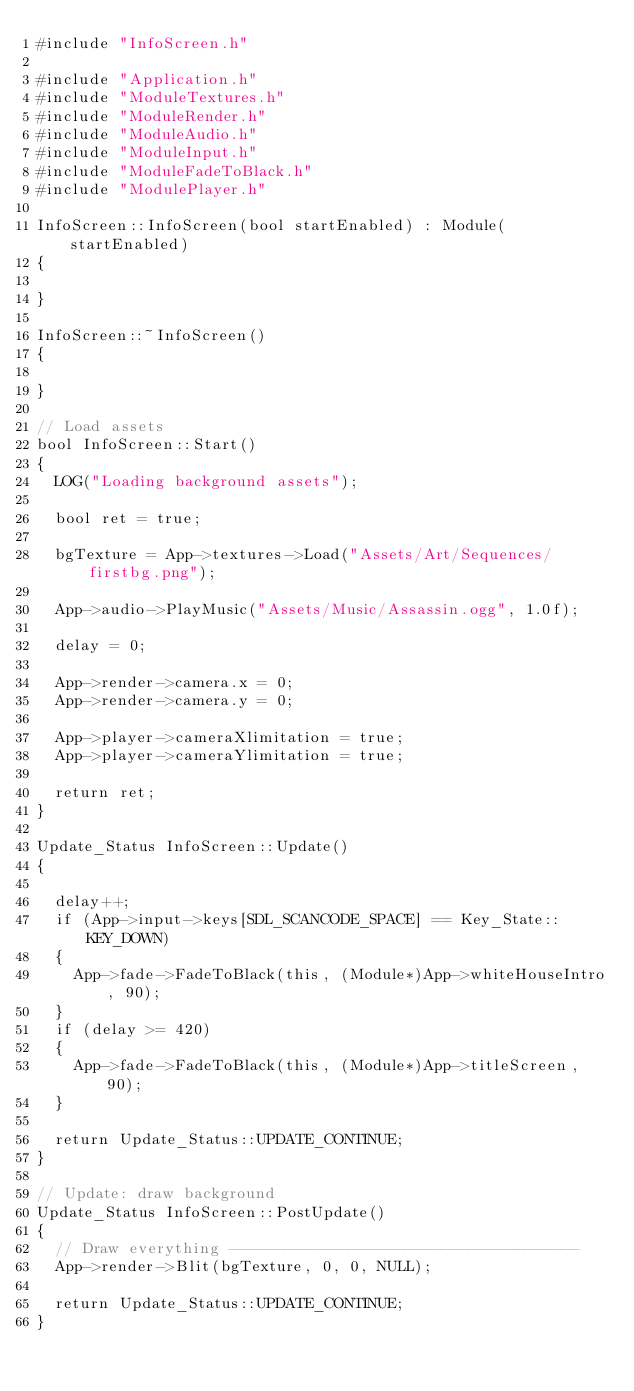<code> <loc_0><loc_0><loc_500><loc_500><_C++_>#include "InfoScreen.h"

#include "Application.h"
#include "ModuleTextures.h"
#include "ModuleRender.h"
#include "ModuleAudio.h"
#include "ModuleInput.h"
#include "ModuleFadeToBlack.h"
#include "ModulePlayer.h"

InfoScreen::InfoScreen(bool startEnabled) : Module(startEnabled)
{

}

InfoScreen::~InfoScreen()
{

}

// Load assets
bool InfoScreen::Start()
{
	LOG("Loading background assets");

	bool ret = true;

	bgTexture = App->textures->Load("Assets/Art/Sequences/firstbg.png");

	App->audio->PlayMusic("Assets/Music/Assassin.ogg", 1.0f);

	delay = 0;

	App->render->camera.x = 0;
	App->render->camera.y = 0;

	App->player->cameraXlimitation = true;
	App->player->cameraYlimitation = true;

	return ret;
}

Update_Status InfoScreen::Update()
{

	delay++;
	if (App->input->keys[SDL_SCANCODE_SPACE] == Key_State::KEY_DOWN)
	{
		App->fade->FadeToBlack(this, (Module*)App->whiteHouseIntro, 90);
	}
	if (delay >= 420)
	{
		App->fade->FadeToBlack(this, (Module*)App->titleScreen, 90);
	}

	return Update_Status::UPDATE_CONTINUE;
}

// Update: draw background
Update_Status InfoScreen::PostUpdate()
{
	// Draw everything --------------------------------------
	App->render->Blit(bgTexture, 0, 0, NULL);

	return Update_Status::UPDATE_CONTINUE;
}</code> 